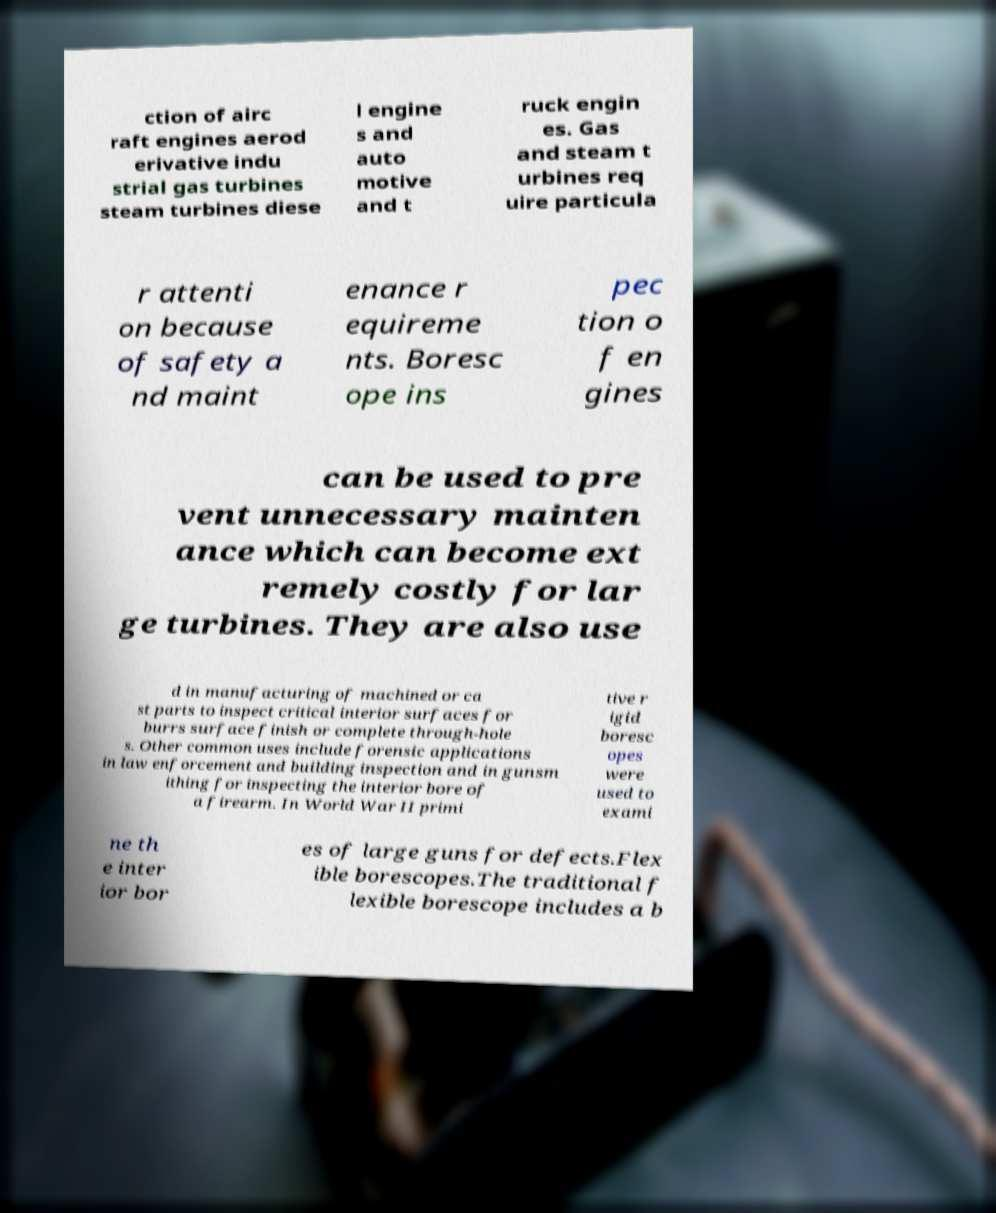Can you read and provide the text displayed in the image?This photo seems to have some interesting text. Can you extract and type it out for me? ction of airc raft engines aerod erivative indu strial gas turbines steam turbines diese l engine s and auto motive and t ruck engin es. Gas and steam t urbines req uire particula r attenti on because of safety a nd maint enance r equireme nts. Boresc ope ins pec tion o f en gines can be used to pre vent unnecessary mainten ance which can become ext remely costly for lar ge turbines. They are also use d in manufacturing of machined or ca st parts to inspect critical interior surfaces for burrs surface finish or complete through-hole s. Other common uses include forensic applications in law enforcement and building inspection and in gunsm ithing for inspecting the interior bore of a firearm. In World War II primi tive r igid boresc opes were used to exami ne th e inter ior bor es of large guns for defects.Flex ible borescopes.The traditional f lexible borescope includes a b 